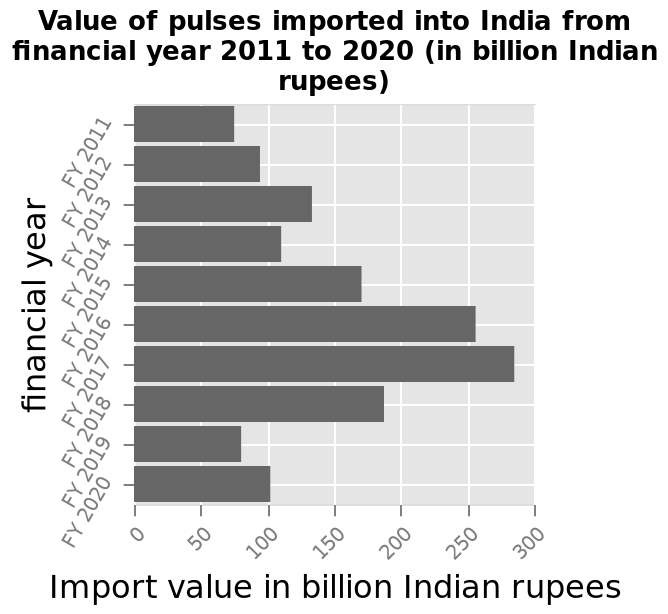<image>
What is the title or name of the bar graph? The bar graph is named "Value of pulses imported into India from financial year 2011 to 2020 (in billion Indian rupees)." 